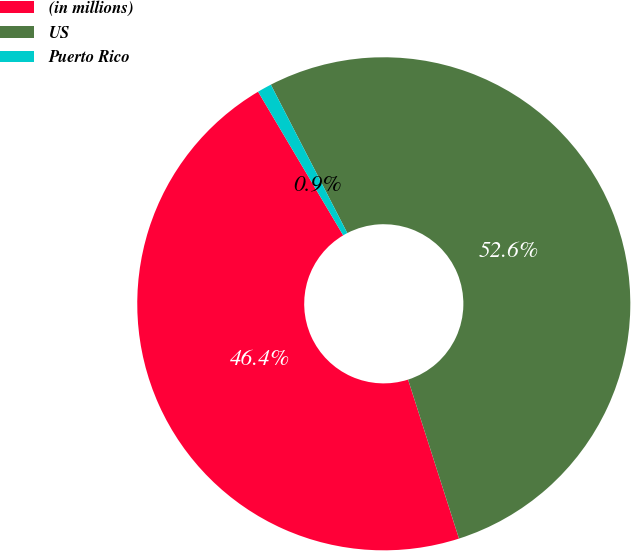Convert chart to OTSL. <chart><loc_0><loc_0><loc_500><loc_500><pie_chart><fcel>(in millions)<fcel>US<fcel>Puerto Rico<nl><fcel>46.42%<fcel>52.64%<fcel>0.94%<nl></chart> 